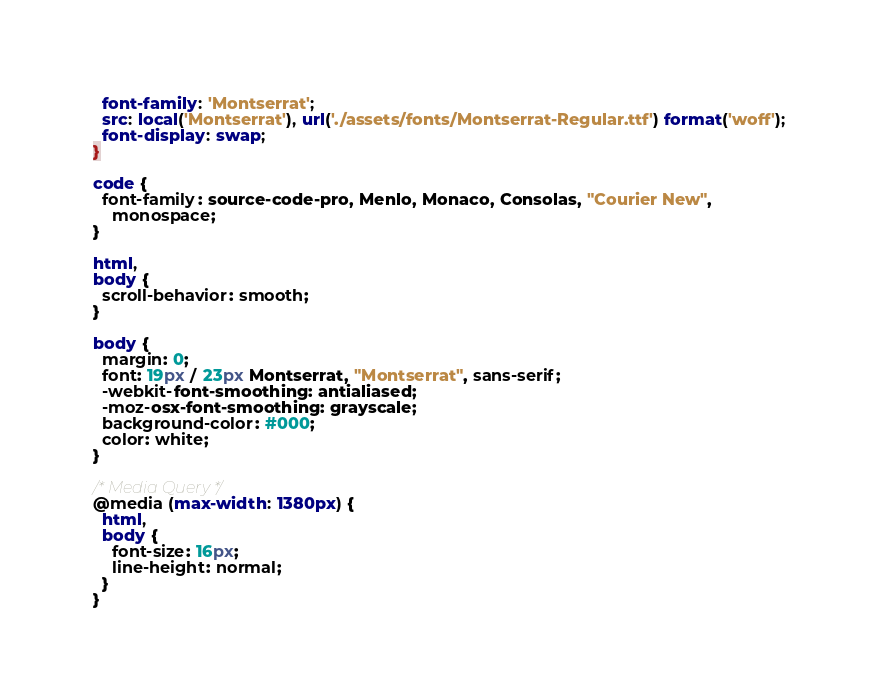Convert code to text. <code><loc_0><loc_0><loc_500><loc_500><_CSS_>  font-family: 'Montserrat';
  src: local('Montserrat'), url('./assets/fonts/Montserrat-Regular.ttf') format('woff');
  font-display: swap;
}

code {
  font-family: source-code-pro, Menlo, Monaco, Consolas, "Courier New",
    monospace;
}

html,
body {
  scroll-behavior: smooth;
}

body {
  margin: 0;
  font: 19px / 23px Montserrat, "Montserrat", sans-serif;
  -webkit-font-smoothing: antialiased;
  -moz-osx-font-smoothing: grayscale;
  background-color: #000;
  color: white;
}

/* Media Query */
@media (max-width: 1380px) {
  html,
  body {
    font-size: 16px;
    line-height: normal;
  }
}
</code> 